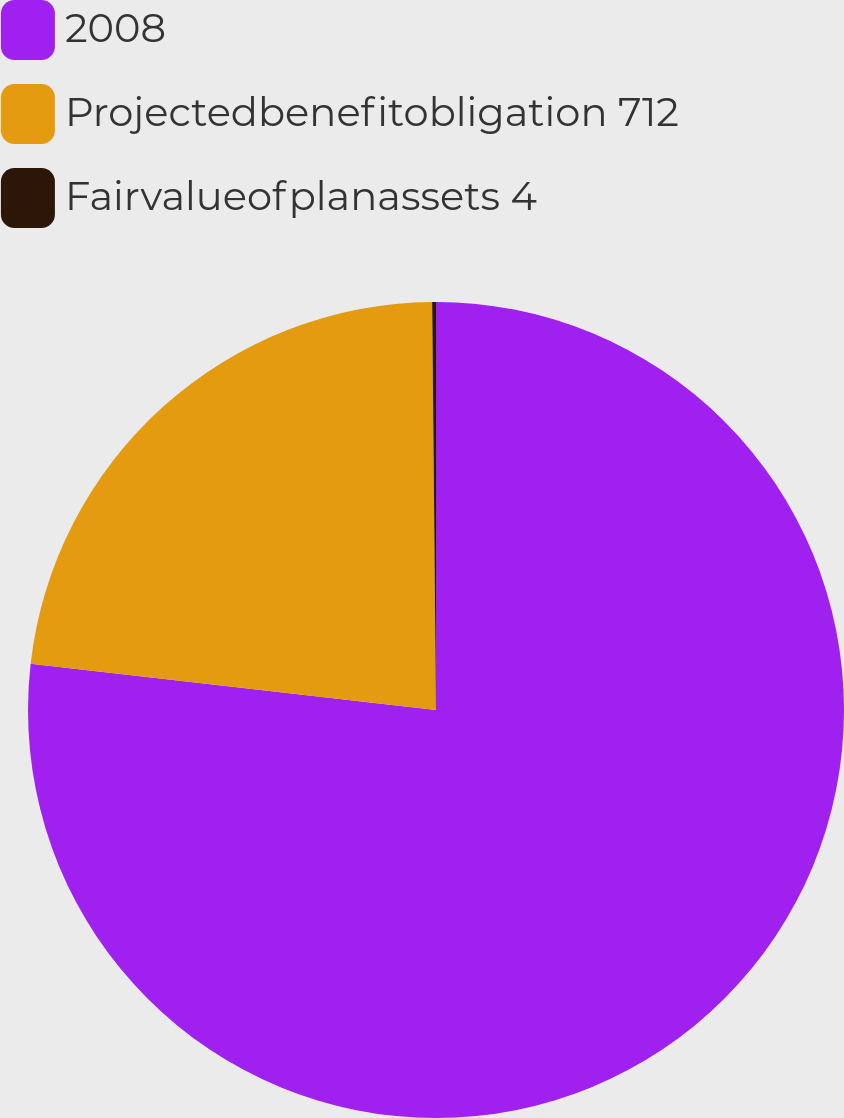<chart> <loc_0><loc_0><loc_500><loc_500><pie_chart><fcel>2008<fcel>Projectedbenefitobligation 712<fcel>Fairvalueofplanassets 4<nl><fcel>76.81%<fcel>23.04%<fcel>0.15%<nl></chart> 